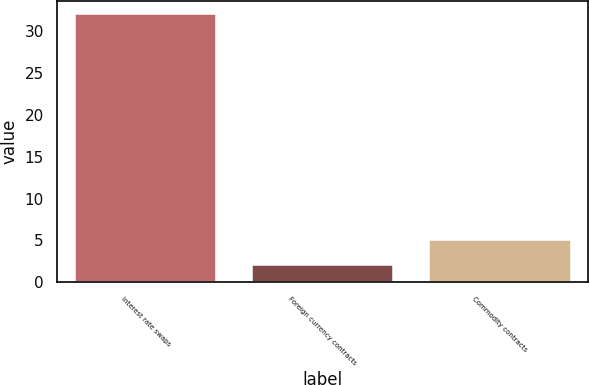Convert chart. <chart><loc_0><loc_0><loc_500><loc_500><bar_chart><fcel>Interest rate swaps<fcel>Foreign currency contracts<fcel>Commodity contracts<nl><fcel>32<fcel>2<fcel>5<nl></chart> 